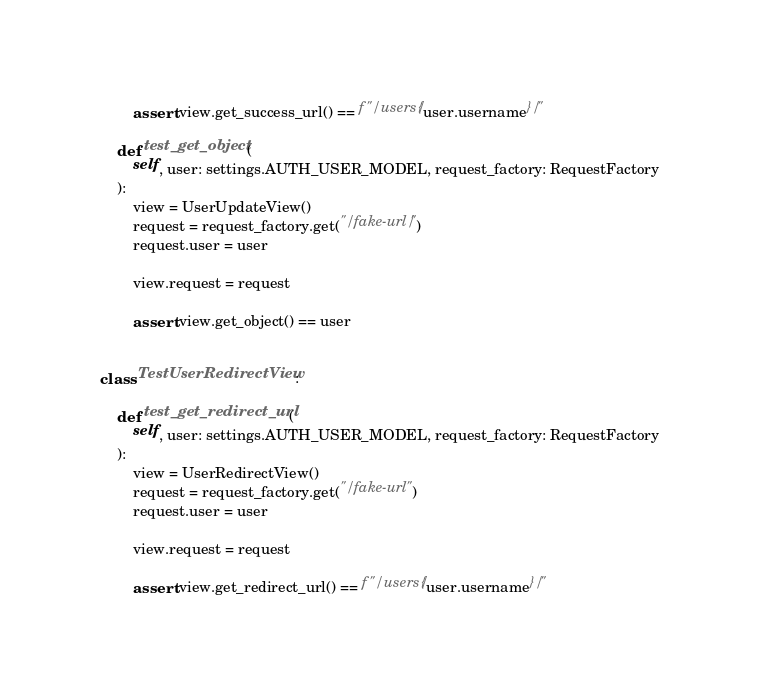<code> <loc_0><loc_0><loc_500><loc_500><_Python_>
        assert view.get_success_url() == f"/users/{user.username}/"

    def test_get_object(
        self, user: settings.AUTH_USER_MODEL, request_factory: RequestFactory
    ):
        view = UserUpdateView()
        request = request_factory.get("/fake-url/")
        request.user = user

        view.request = request

        assert view.get_object() == user


class TestUserRedirectView:

    def test_get_redirect_url(
        self, user: settings.AUTH_USER_MODEL, request_factory: RequestFactory
    ):
        view = UserRedirectView()
        request = request_factory.get("/fake-url")
        request.user = user

        view.request = request

        assert view.get_redirect_url() == f"/users/{user.username}/"
</code> 